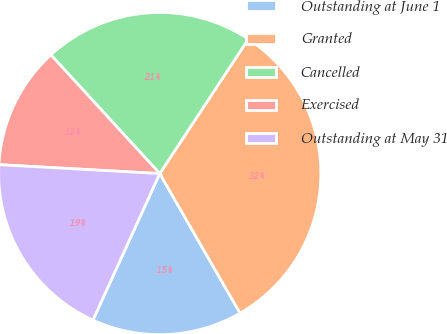Convert chart to OTSL. <chart><loc_0><loc_0><loc_500><loc_500><pie_chart><fcel>Outstanding at June 1<fcel>Granted<fcel>Cancelled<fcel>Exercised<fcel>Outstanding at May 31<nl><fcel>15.12%<fcel>32.42%<fcel>21.08%<fcel>12.31%<fcel>19.07%<nl></chart> 